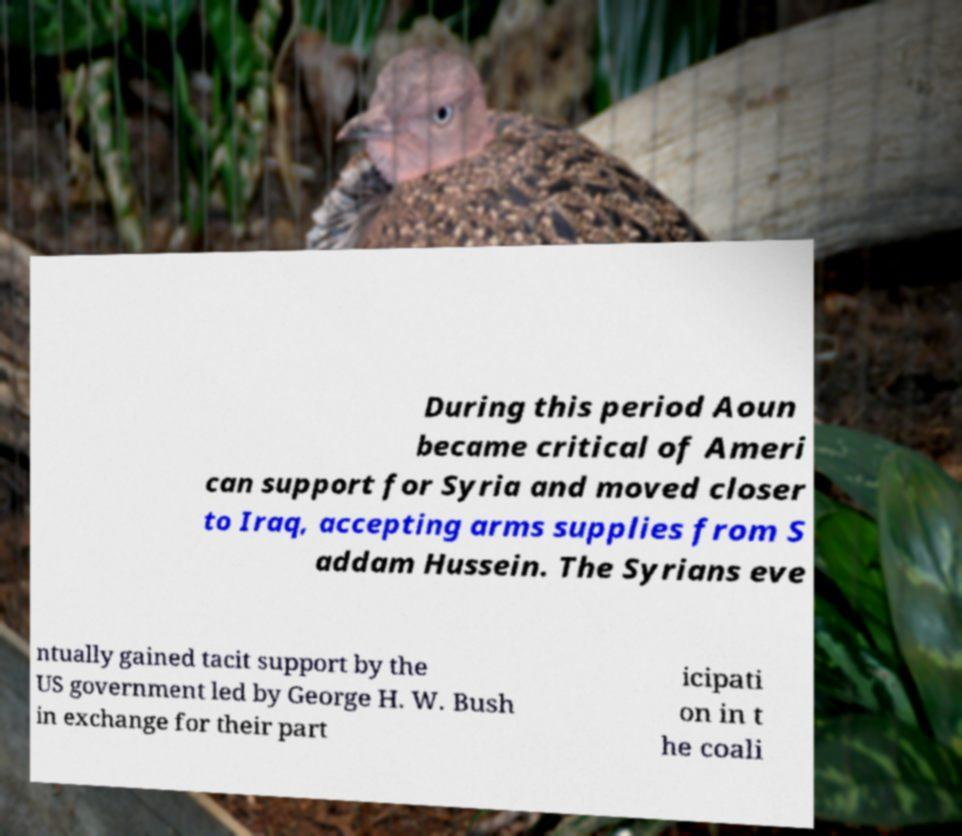I need the written content from this picture converted into text. Can you do that? During this period Aoun became critical of Ameri can support for Syria and moved closer to Iraq, accepting arms supplies from S addam Hussein. The Syrians eve ntually gained tacit support by the US government led by George H. W. Bush in exchange for their part icipati on in t he coali 